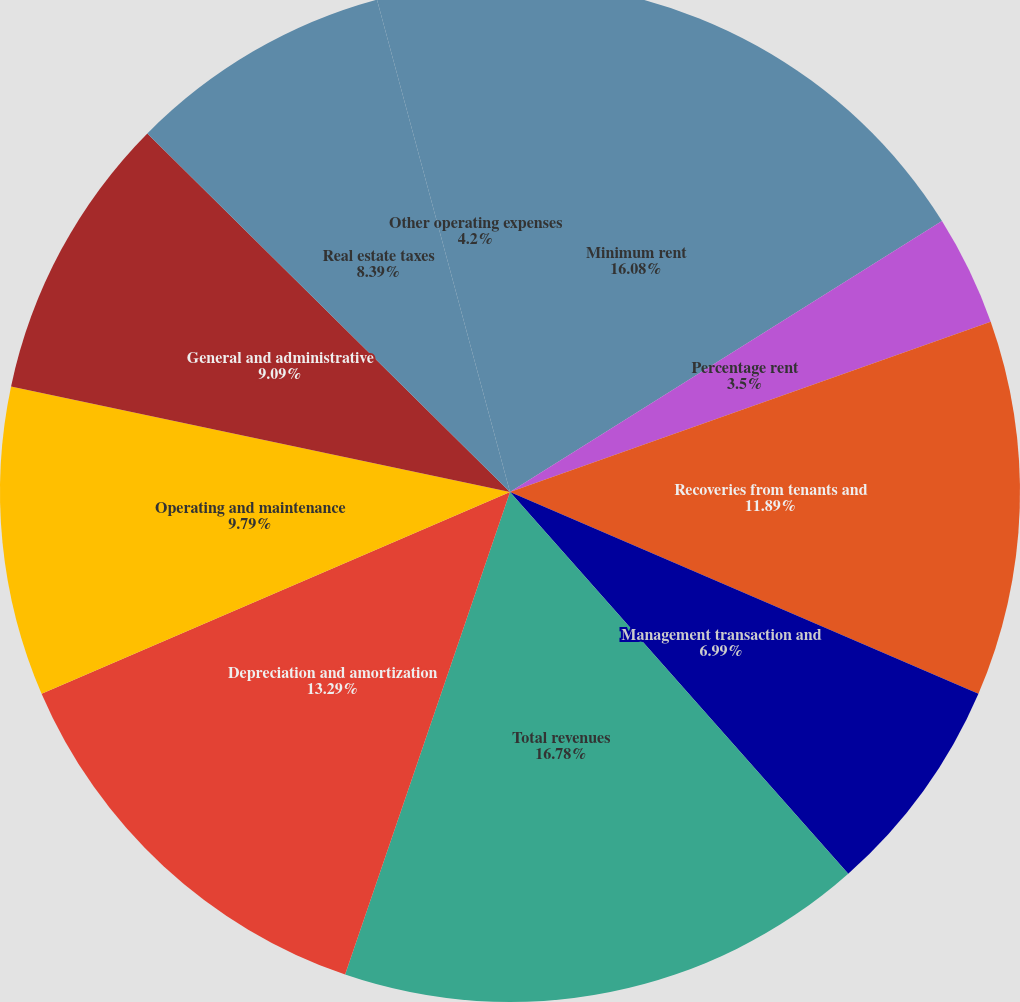Convert chart to OTSL. <chart><loc_0><loc_0><loc_500><loc_500><pie_chart><fcel>Minimum rent<fcel>Percentage rent<fcel>Recoveries from tenants and<fcel>Management transaction and<fcel>Total revenues<fcel>Depreciation and amortization<fcel>Operating and maintenance<fcel>General and administrative<fcel>Real estate taxes<fcel>Other operating expenses<nl><fcel>16.08%<fcel>3.5%<fcel>11.89%<fcel>6.99%<fcel>16.78%<fcel>13.29%<fcel>9.79%<fcel>9.09%<fcel>8.39%<fcel>4.2%<nl></chart> 